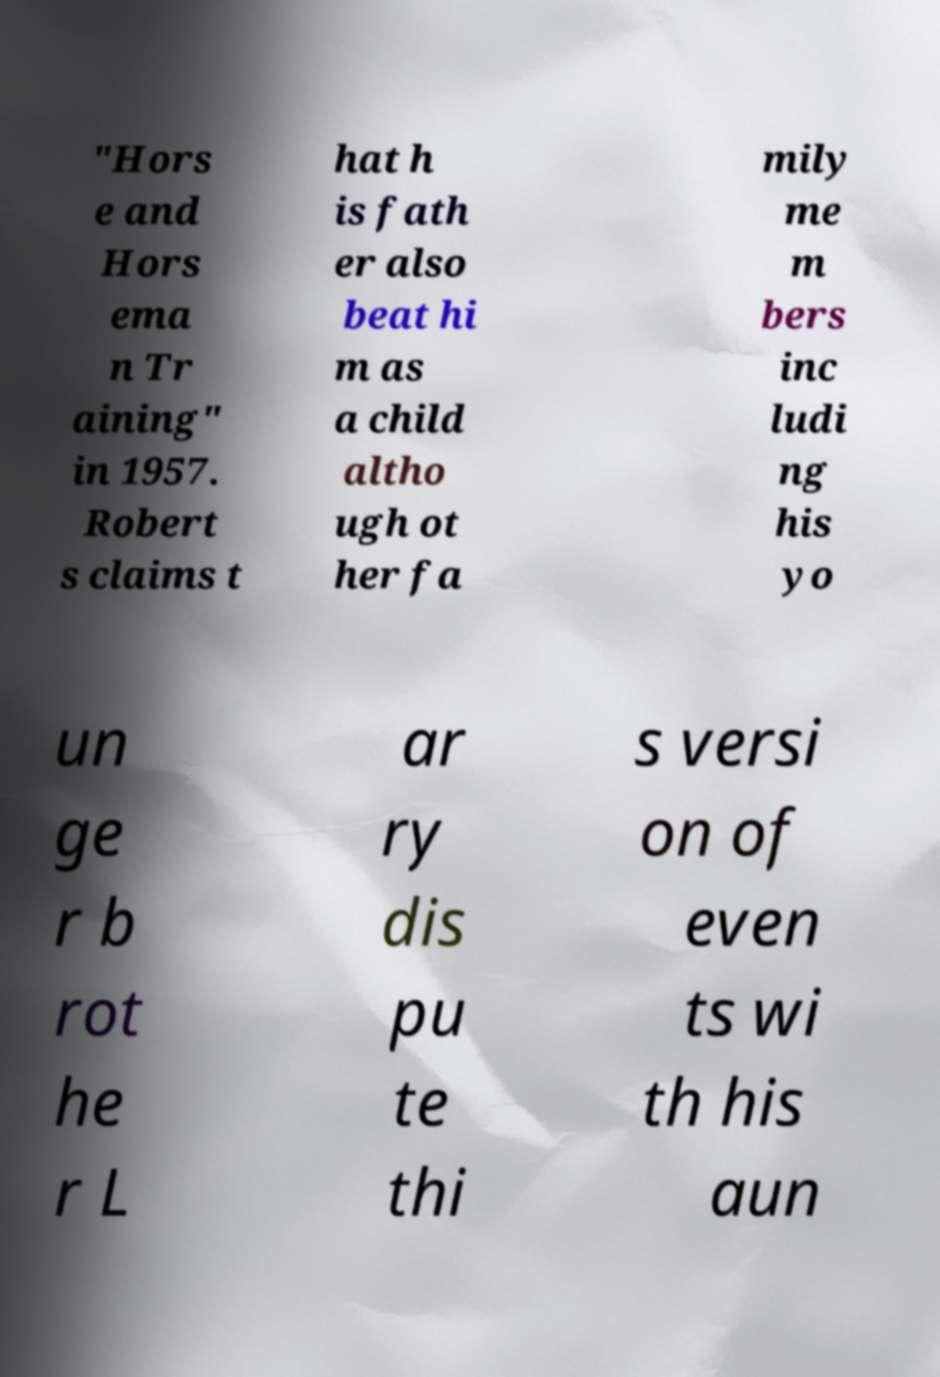Please read and relay the text visible in this image. What does it say? "Hors e and Hors ema n Tr aining" in 1957. Robert s claims t hat h is fath er also beat hi m as a child altho ugh ot her fa mily me m bers inc ludi ng his yo un ge r b rot he r L ar ry dis pu te thi s versi on of even ts wi th his aun 